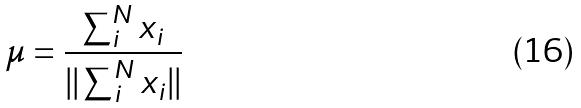<formula> <loc_0><loc_0><loc_500><loc_500>\mu = \frac { \sum _ { i } ^ { N } x _ { i } } { | | \sum _ { i } ^ { N } x _ { i } | | }</formula> 